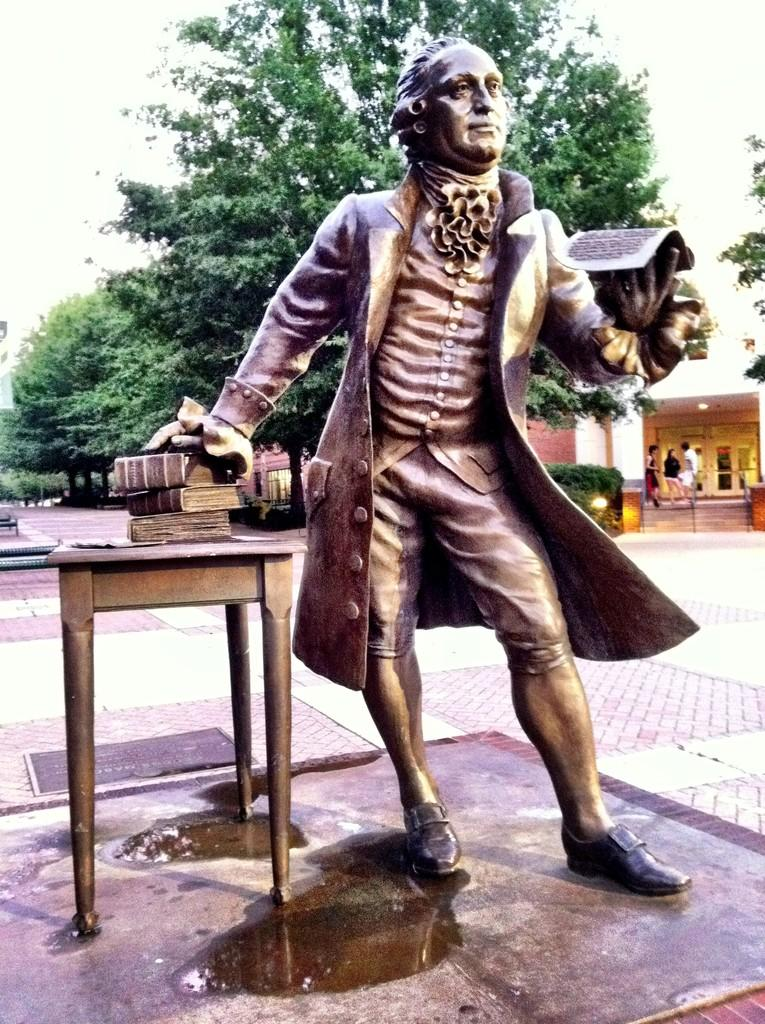What is the main subject of the image? There is a statue of a man in the image. How is the statue positioned? The statue is standing. What is located near the statue? There is a table in the image. What can be found on the table? There are books on the table. What is visible in the background behind the statue? There is a tree visible behind the statue. What type of structure is present in the image? There is a house in the image. What type of soup is being served in the bowl on the table? There is no bowl or soup present in the image; it only features a table with books on it. 